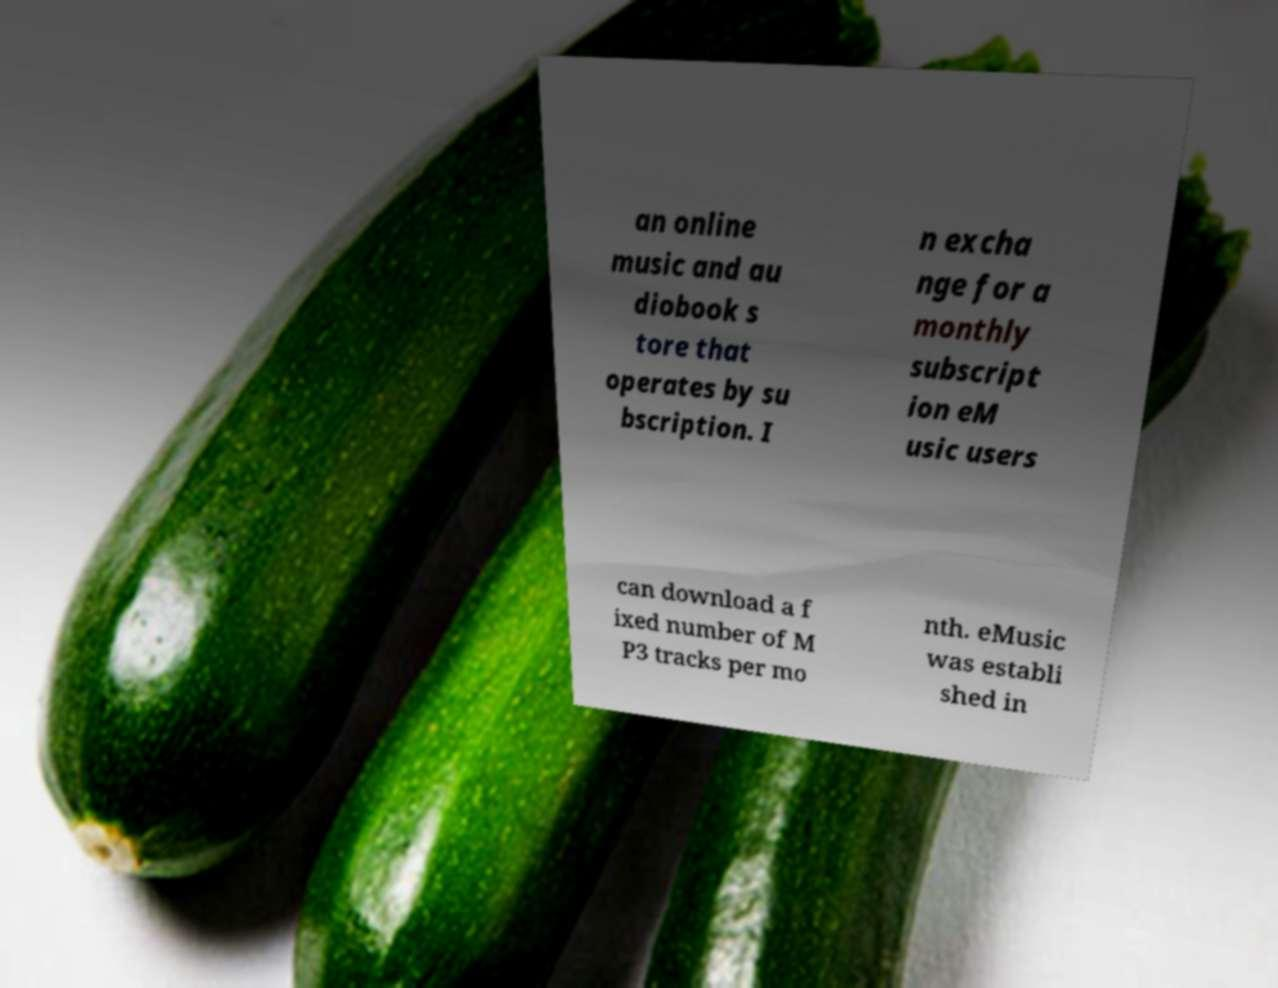I need the written content from this picture converted into text. Can you do that? an online music and au diobook s tore that operates by su bscription. I n excha nge for a monthly subscript ion eM usic users can download a f ixed number of M P3 tracks per mo nth. eMusic was establi shed in 